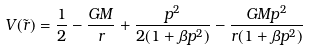<formula> <loc_0><loc_0><loc_500><loc_500>V ( \tilde { r } ) = \frac { 1 } { 2 } - \frac { G M } { r } + \frac { p ^ { 2 } } { 2 ( 1 + \beta p ^ { 2 } ) } - \frac { G M p ^ { 2 } } { r ( 1 + \beta p ^ { 2 } ) }</formula> 